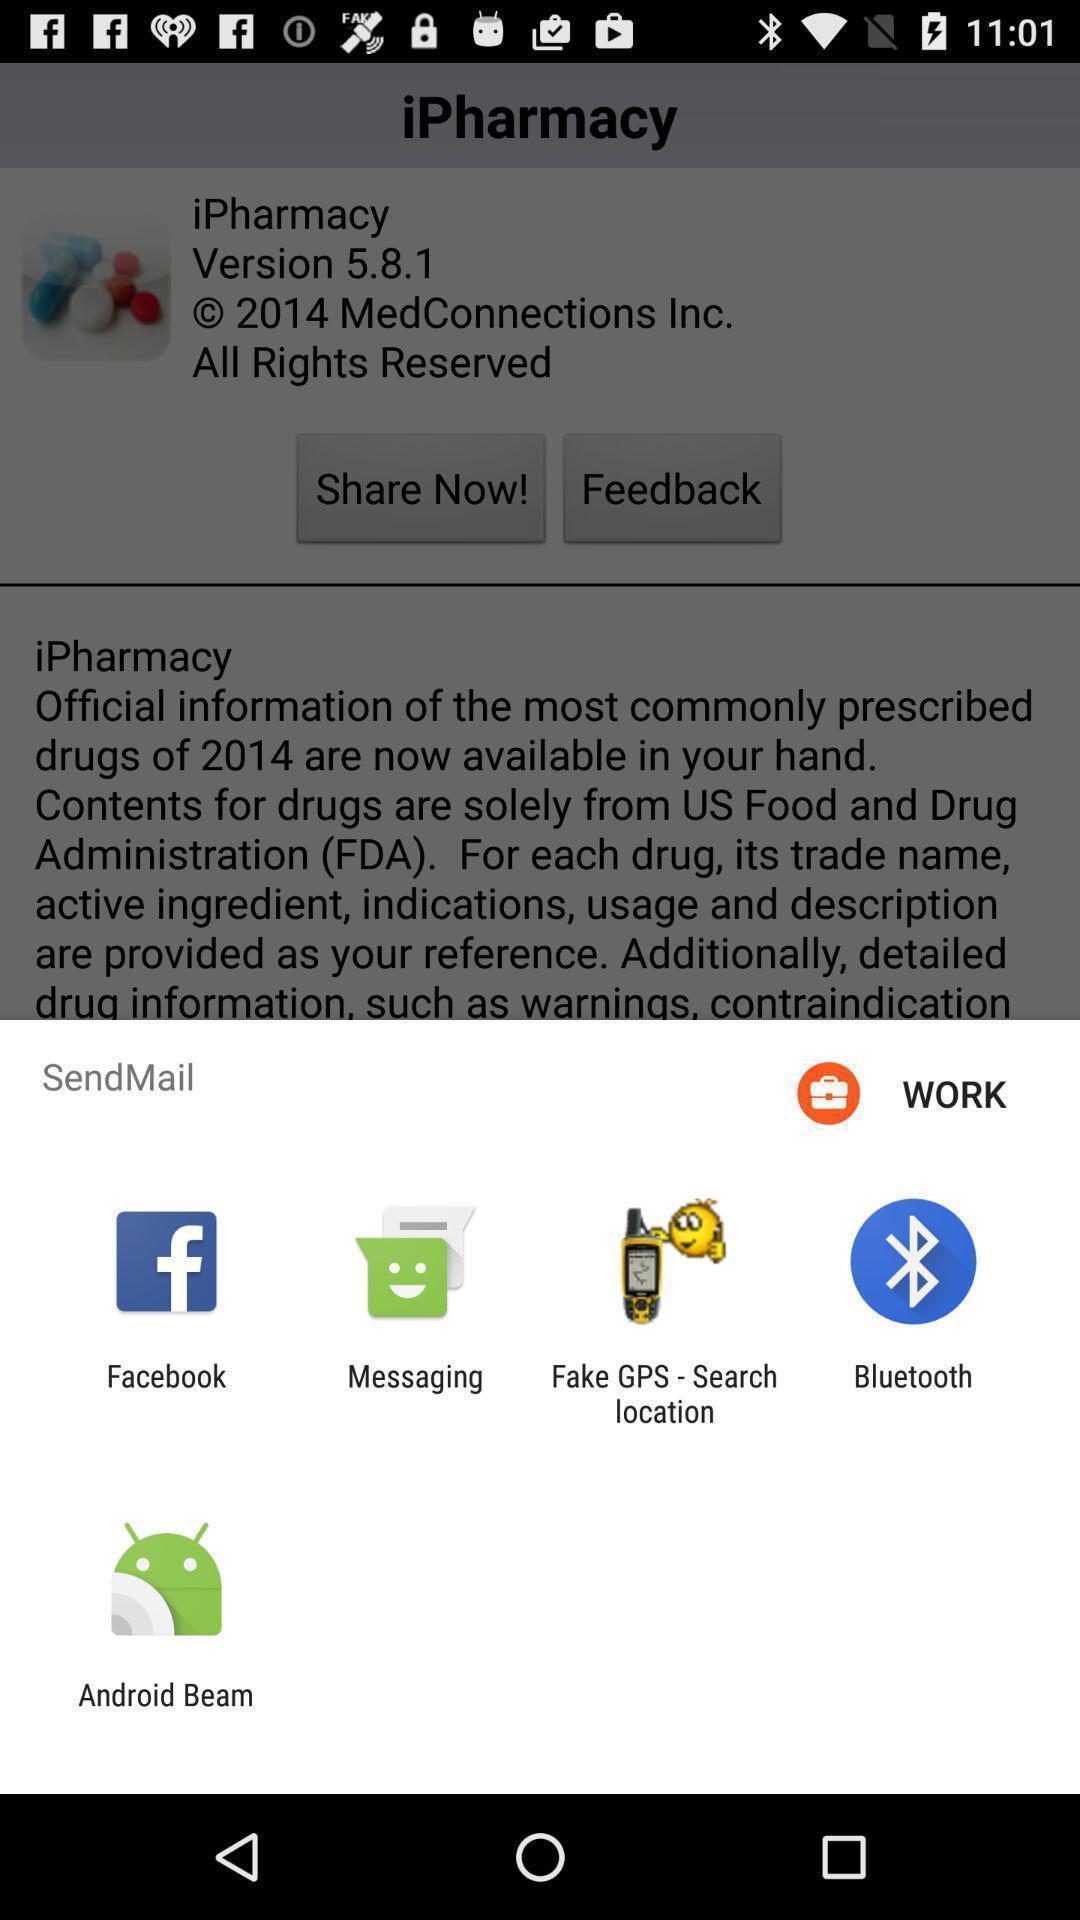What can you discern from this picture? Pop up to send mail through various applications. 